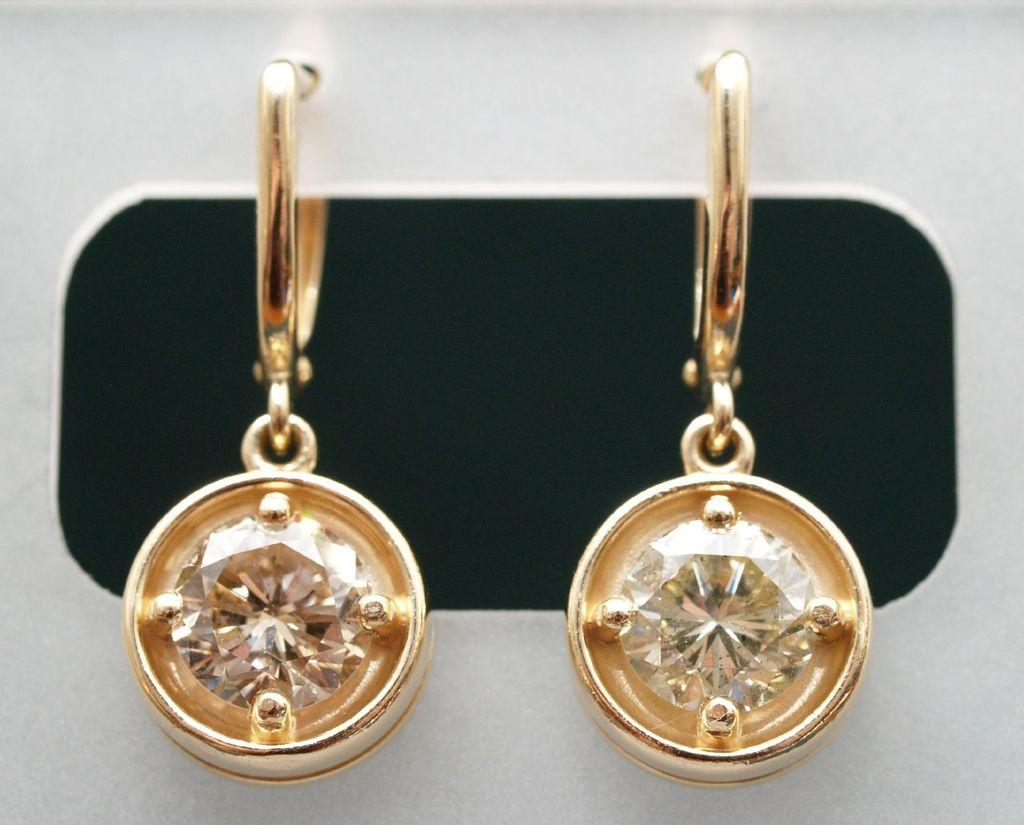What type of accessory is present in the image? There is a pair of earrings in the image. Can you describe the earrings in more detail? Unfortunately, the image does not provide enough detail to describe the earrings further. How many times does the person in the image sneeze? There is no person present in the image, only a pair of earrings. What type of base is used to display the earrings in the image? There is no base visible in the image; the earrings are not displayed on any surface. 